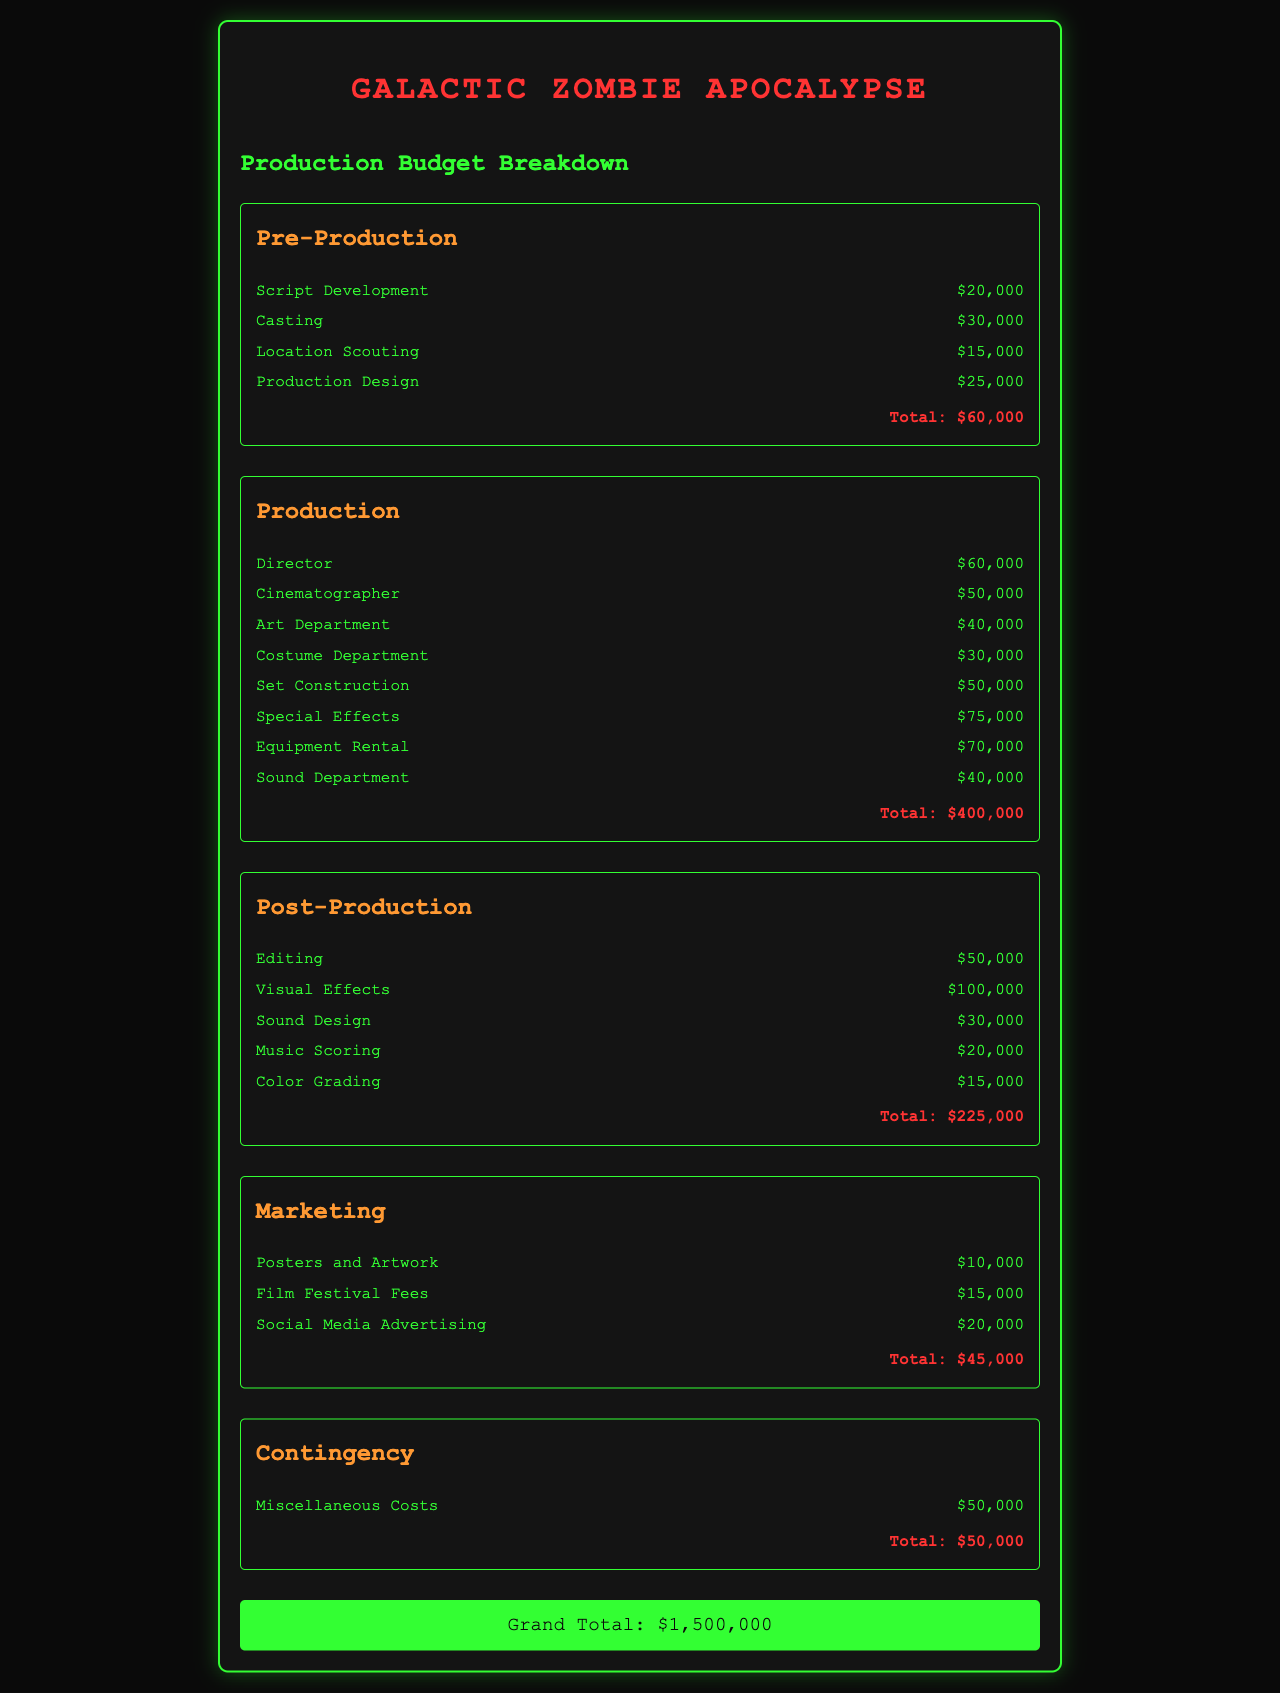What is the total budget for Pre-Production? The total budget for Pre-Production is clearly stated at the end of that section, which is $60,000.
Answer: $60,000 How much is allocated for Special Effects? The expense for Special Effects is specifically listed in the Production section as $75,000.
Answer: $75,000 What is the highest expense in Production? The highest expense can be determined by comparing all line items in the Production section, which is the Equipment Rental at $70,000.
Answer: $70,000 What is the total budget for Marketing? The total budget for Marketing is detailed at the end of the Marketing section, which sums to $45,000.
Answer: $45,000 What is the grand total budget for the film? The grand total is prominently shown at the bottom of the document, which consolidates all costs to $1,500,000.
Answer: $1,500,000 How much is allocated for Visual Effects in Post-Production? The amount for Visual Effects is stated within the Post-Production expenses, which is $100,000.
Answer: $100,000 What is the total cost for the Sound Department during Production? The cost for the Sound Department is listed under Production expenses as $40,000, confirming its value.
Answer: $40,000 What does the contingency budget cover? The contingency budget covers Miscellaneous Costs, explicitly mentioned as $50,000 in that section.
Answer: Miscellaneous Costs Which department has the least allocated budget? By comparing total amounts across all departments, Marketing has the least allocated budget at $45,000.
Answer: $45,000 